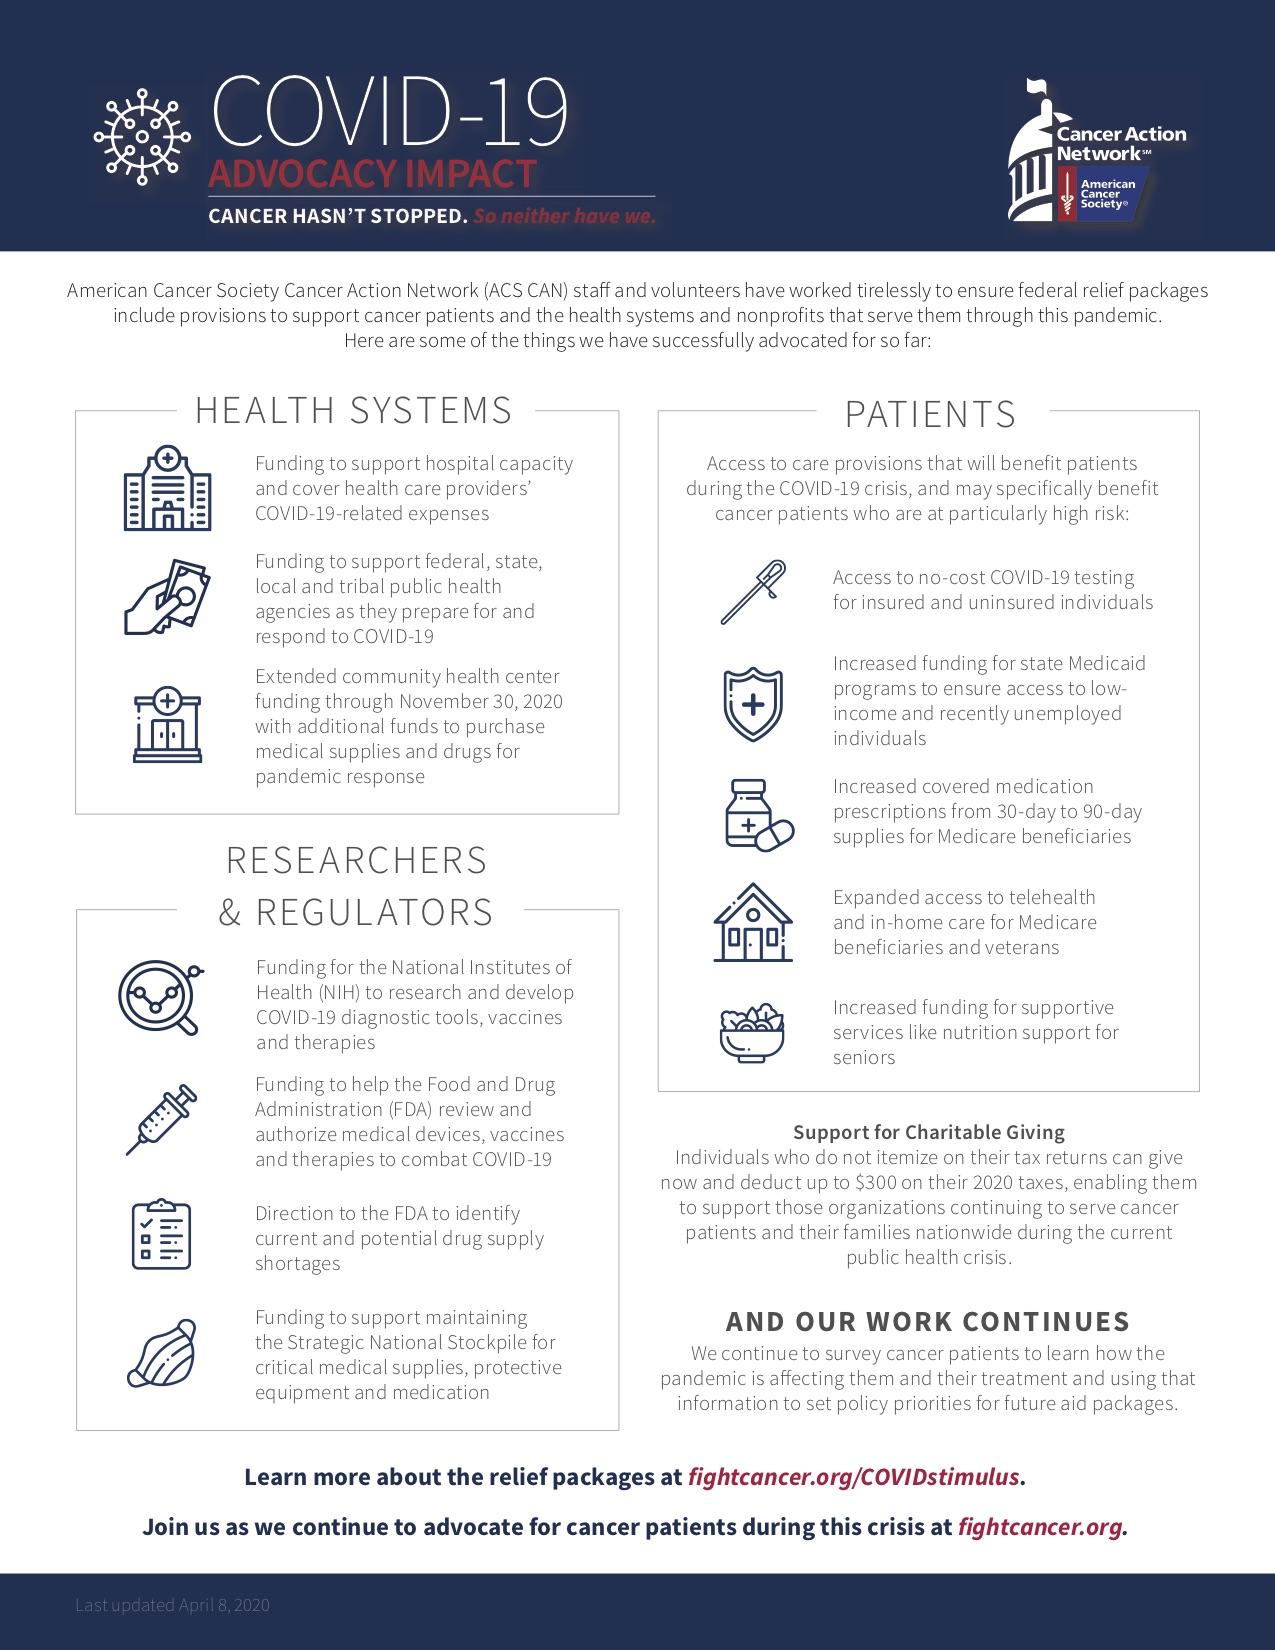Point out several critical features in this image. The Medicaid program is designed to provide coverage to low-income and recently unemployed individuals who may not have access to health insurance through other means. The provision of no-cost COVID-19 testing is made available to both insured and uninsured individuals. The Strategic National Stockpile is equipped with three essential items: critical medical supplies, protective equipment, and medication. Three benefits are available for the health system. The benefits available for senior patients include increased funding for supportive services such as nutrition support. 